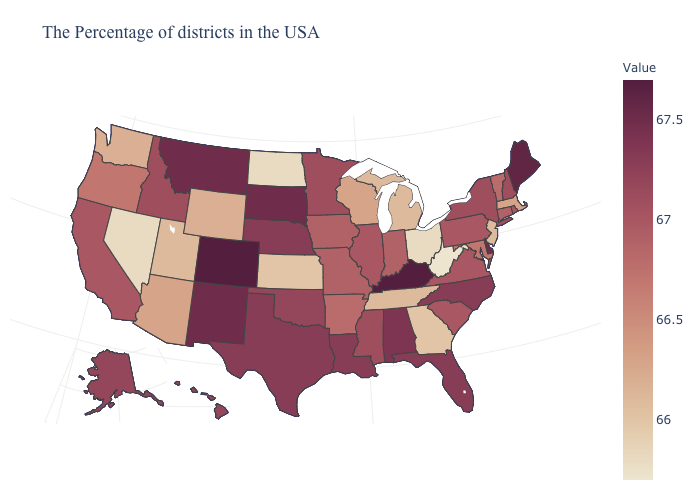Does New Jersey have a higher value than New York?
Be succinct. No. Which states have the lowest value in the Northeast?
Quick response, please. New Jersey. Which states hav the highest value in the South?
Short answer required. Kentucky. Which states have the highest value in the USA?
Write a very short answer. Kentucky, Colorado. Which states have the lowest value in the USA?
Answer briefly. West Virginia. Is the legend a continuous bar?
Short answer required. Yes. Among the states that border Oregon , which have the lowest value?
Concise answer only. Nevada. Which states have the highest value in the USA?
Be succinct. Kentucky, Colorado. Which states have the highest value in the USA?
Keep it brief. Kentucky, Colorado. 